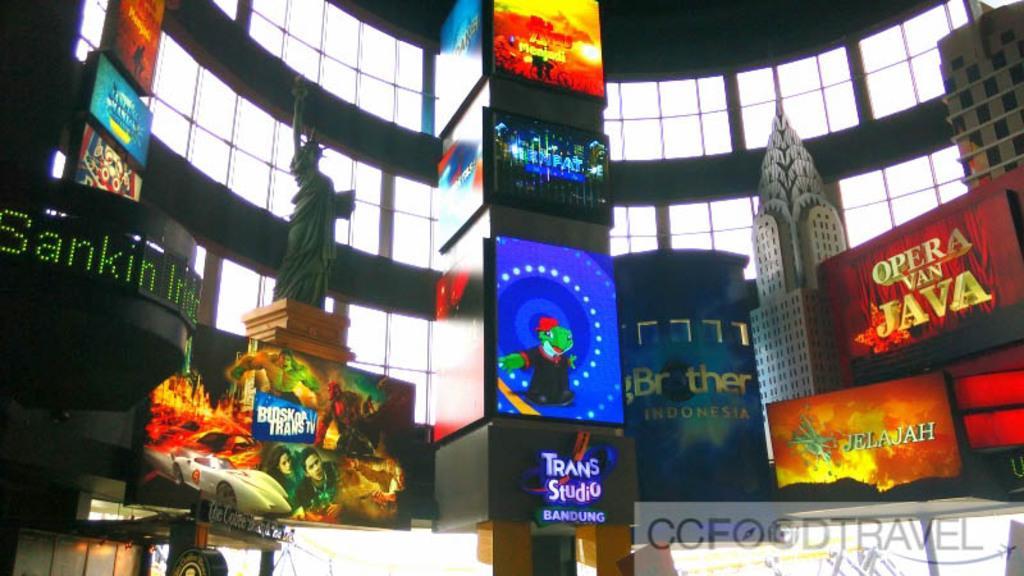Could you give a brief overview of what you see in this image? In the image there are many posters and screen with images on it. And also there is a pillar with posters. There is a statue and also there are models of buildings. Behind them there is a wall with glasses and pillars. In the bottom right corner of the image there is watermark. And there are some other things at the bottom of the image. 